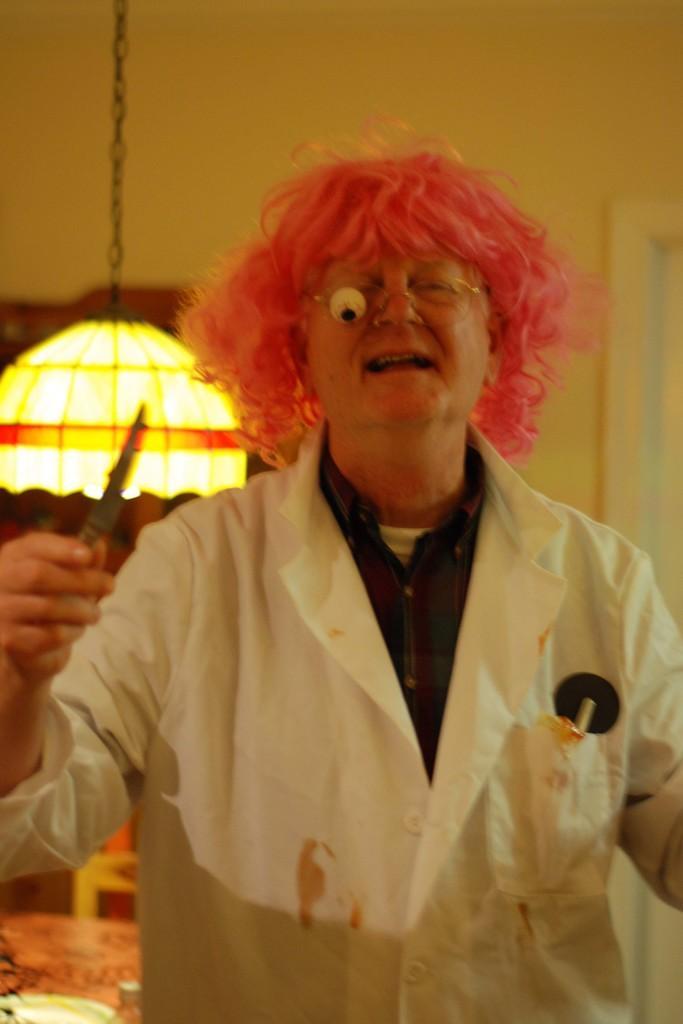Describe this image in one or two sentences. In this image, we can see a person wearing clothes and holding an object with his hand. There is a light on the left side of the image. 